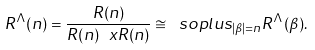Convert formula to latex. <formula><loc_0><loc_0><loc_500><loc_500>R ^ { \Lambda } ( n ) = \frac { R ( n ) } { R ( n ) \ x R ( n ) } \cong \ s o p l u s _ { | \beta | = n } R ^ { \Lambda } ( \beta ) .</formula> 